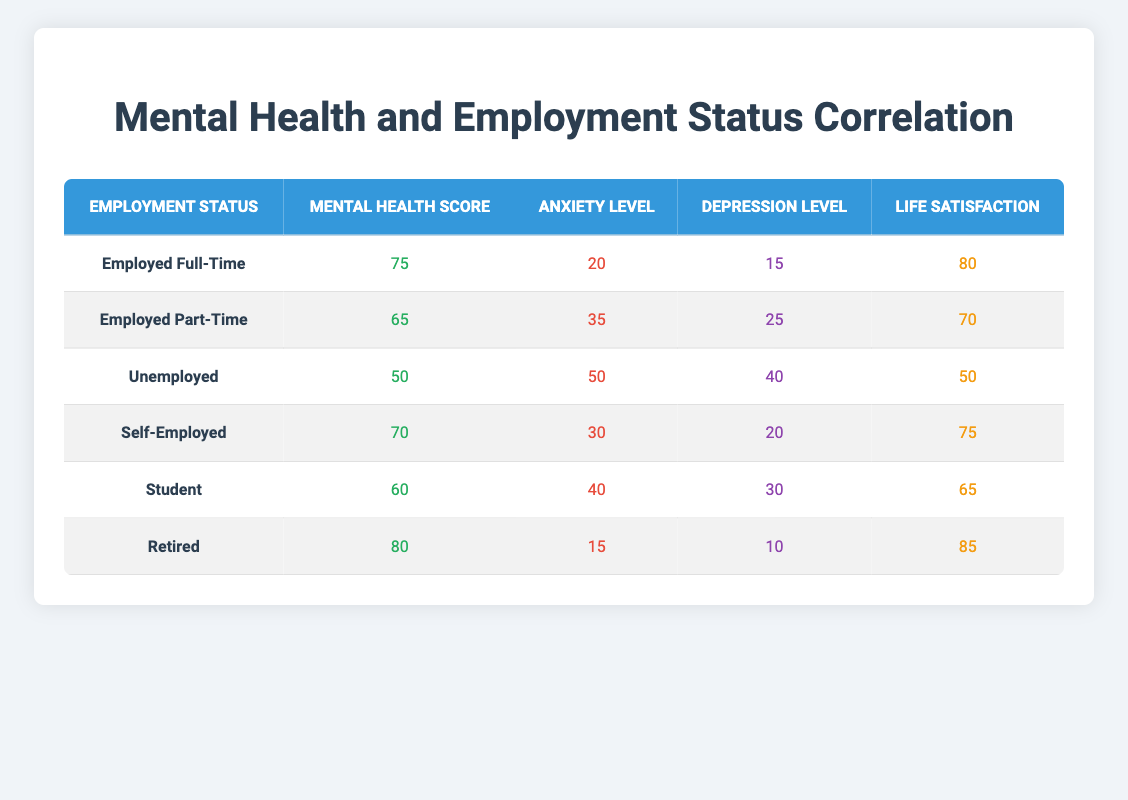What is the Mental Health Score for Employed Part-Time individuals? The table shows the "Mental Health Score" for "Employed Part-Time" individuals to be 65.
Answer: 65 What is the average Life Satisfaction among unemployed individuals? The table indicates that the Life Satisfaction for Unemployed individuals is 50, as there is only one entry for this category. Thus, the average is simply 50.
Answer: 50 Is the Anxiety Level higher for Self-Employed individuals compared to those who are Employed Full-Time? The Anxiety Level for Self-Employed individuals is 30, while for Employed Full-Time, it is 20. Since 30 is greater than 20, the statement is true.
Answer: Yes What is the difference in Mental Health Scores between those who are Retired and those who are Unemployed? The Mental Health Score for Retired individuals is 80, and for Unemployed individuals, it is 50. The difference is calculated as 80 - 50 = 30.
Answer: 30 Which Employment Status has the lowest Depression Level? By examining the table, we see the Depression Level for each status: Employed Full-Time (15), Employed Part-Time (25), Unemployed (40), Self-Employed (20), Student (30), and Retired (10). The lowest value is 10 for Retired.
Answer: Retired What is the average Anxiety Level among all groups? To find the average Anxiety Level, we add all the levels: 20 (Full-Time) + 35 (Part-Time) + 50 (Unemployed) + 30 (Self-Employed) + 40 (Student) + 15 (Retired) = 190. There are 6 groups, so we divide 190 by 6 to get approximately 31.67, then rounding gives us 32.
Answer: 32 Does being Employed Full-Time correlate with the highest Life Satisfaction score? A check on the Life Satisfaction scores shows 80 for Employed Full-Time, while Retired has 85, which is higher. Therefore, Employed Full-Time does not correlate with the highest score.
Answer: No What is the range of Mental Health Scores across all employment statuses? The highest Mental Health Score is 80 (Retired) and the lowest is 50 (Unemployed). The range is calculated as 80 - 50 = 30.
Answer: 30 Identify the Employment Status with the best overall mental health indicators based on the scores. Examining all indicators, Retired has the highest Mental Health Score (80), lowest Anxiety Level (15), lowest Depression Level (10), and high Life Satisfaction (85). Therefore, it represents the best overall mental health indicators.
Answer: Retired 